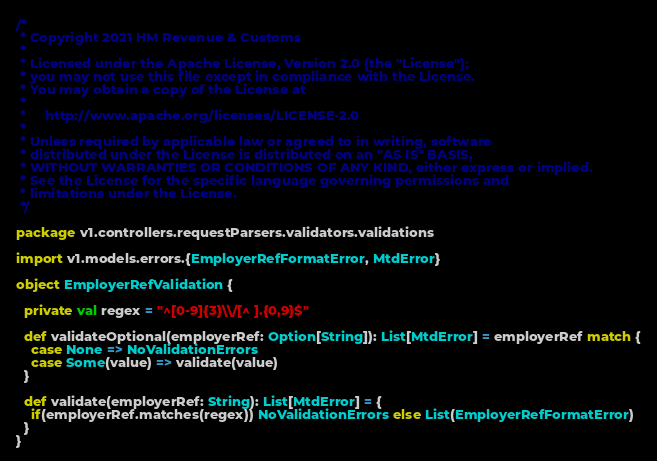Convert code to text. <code><loc_0><loc_0><loc_500><loc_500><_Scala_>/*
 * Copyright 2021 HM Revenue & Customs
 *
 * Licensed under the Apache License, Version 2.0 (the "License");
 * you may not use this file except in compliance with the License.
 * You may obtain a copy of the License at
 *
 *     http://www.apache.org/licenses/LICENSE-2.0
 *
 * Unless required by applicable law or agreed to in writing, software
 * distributed under the License is distributed on an "AS IS" BASIS,
 * WITHOUT WARRANTIES OR CONDITIONS OF ANY KIND, either express or implied.
 * See the License for the specific language governing permissions and
 * limitations under the License.
 */

package v1.controllers.requestParsers.validators.validations

import v1.models.errors.{EmployerRefFormatError, MtdError}

object EmployerRefValidation {

  private val regex = "^[0-9]{3}\\/[^ ].{0,9}$"

  def validateOptional(employerRef: Option[String]): List[MtdError] = employerRef match {
    case None => NoValidationErrors
    case Some(value) => validate(value)
  }

  def validate(employerRef: String): List[MtdError] = {
    if(employerRef.matches(regex)) NoValidationErrors else List(EmployerRefFormatError)
  }
}
</code> 